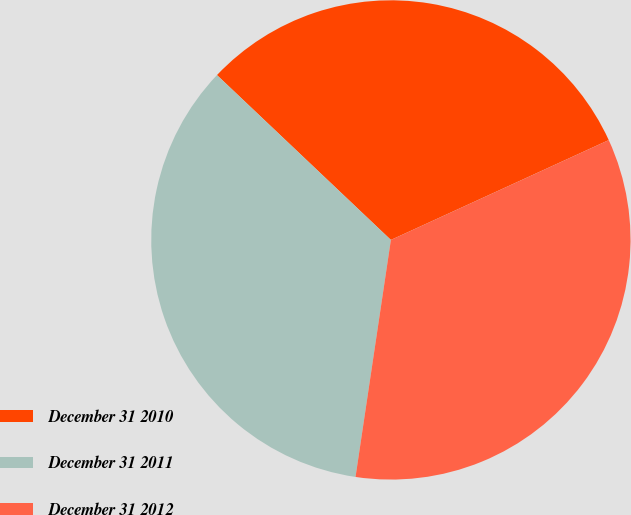Convert chart to OTSL. <chart><loc_0><loc_0><loc_500><loc_500><pie_chart><fcel>December 31 2010<fcel>December 31 2011<fcel>December 31 2012<nl><fcel>31.09%<fcel>34.72%<fcel>34.2%<nl></chart> 